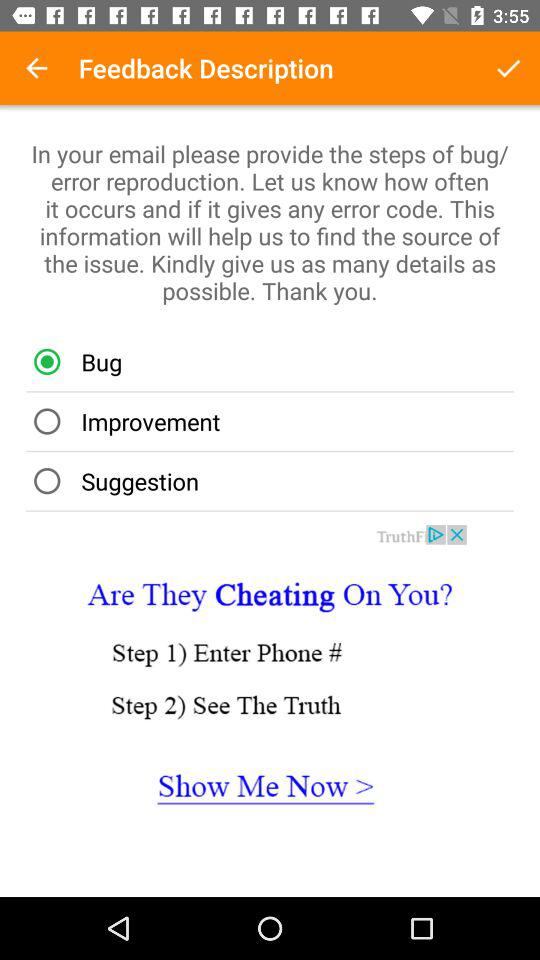Which email do bug reports get sent to?
When the provided information is insufficient, respond with <no answer>. <no answer> 